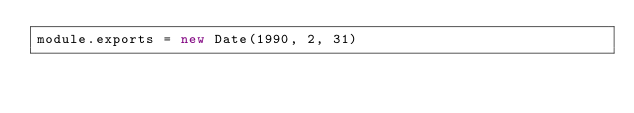<code> <loc_0><loc_0><loc_500><loc_500><_JavaScript_>module.exports = new Date(1990, 2, 31)
</code> 